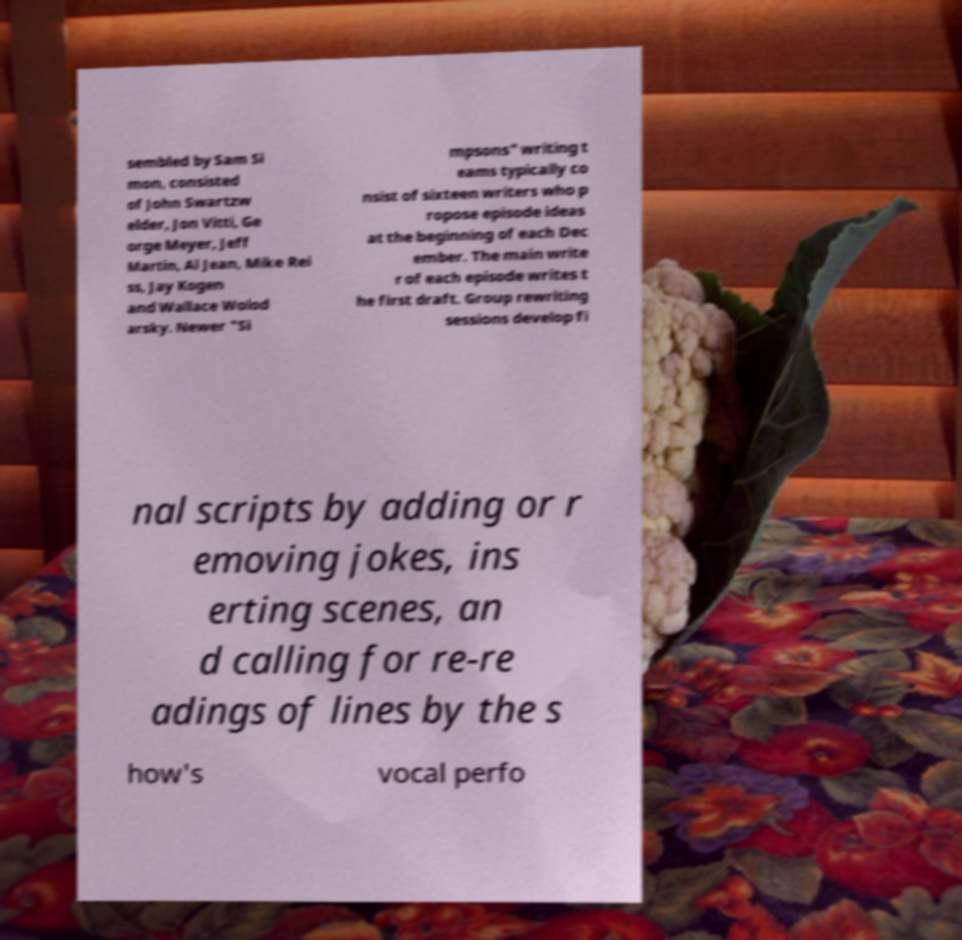Can you read and provide the text displayed in the image?This photo seems to have some interesting text. Can you extract and type it out for me? sembled by Sam Si mon, consisted of John Swartzw elder, Jon Vitti, Ge orge Meyer, Jeff Martin, Al Jean, Mike Rei ss, Jay Kogen and Wallace Wolod arsky. Newer "Si mpsons" writing t eams typically co nsist of sixteen writers who p ropose episode ideas at the beginning of each Dec ember. The main write r of each episode writes t he first draft. Group rewriting sessions develop fi nal scripts by adding or r emoving jokes, ins erting scenes, an d calling for re-re adings of lines by the s how's vocal perfo 